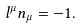Convert formula to latex. <formula><loc_0><loc_0><loc_500><loc_500>l ^ { \mu } n _ { \mu } = - 1 .</formula> 